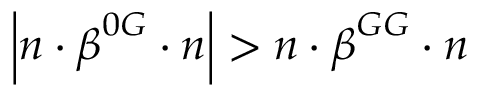Convert formula to latex. <formula><loc_0><loc_0><loc_500><loc_500>\left | n \cdot \beta ^ { 0 G } \cdot n \right | > n \cdot \beta ^ { G G } \cdot n</formula> 